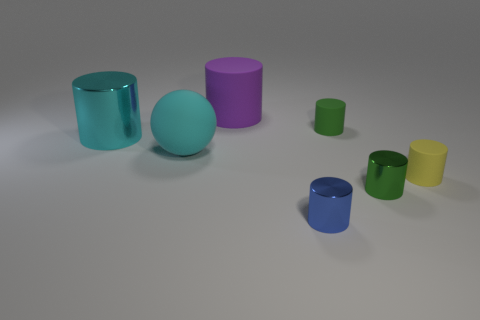Subtract all tiny shiny cylinders. How many cylinders are left? 4 Subtract 3 cylinders. How many cylinders are left? 3 Subtract all cyan cylinders. How many cylinders are left? 5 Add 2 yellow cubes. How many objects exist? 9 Subtract all blue cylinders. Subtract all purple balls. How many cylinders are left? 5 Subtract all spheres. How many objects are left? 6 Add 4 purple rubber cylinders. How many purple rubber cylinders are left? 5 Add 4 tiny green objects. How many tiny green objects exist? 6 Subtract 0 red spheres. How many objects are left? 7 Subtract all tiny green cubes. Subtract all tiny blue shiny objects. How many objects are left? 6 